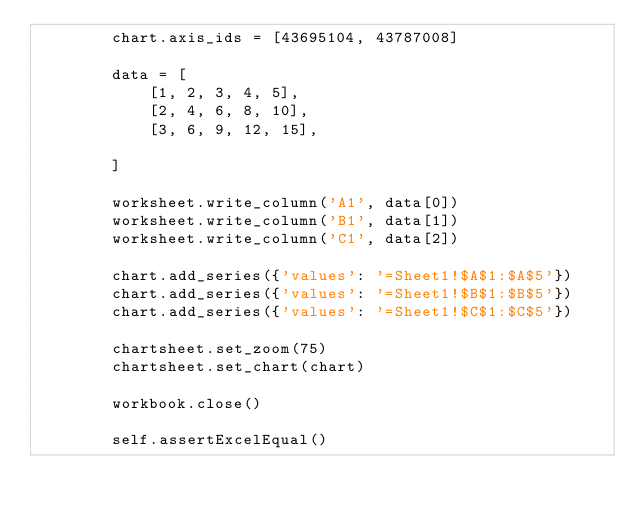Convert code to text. <code><loc_0><loc_0><loc_500><loc_500><_Python_>        chart.axis_ids = [43695104, 43787008]

        data = [
            [1, 2, 3, 4, 5],
            [2, 4, 6, 8, 10],
            [3, 6, 9, 12, 15],

        ]

        worksheet.write_column('A1', data[0])
        worksheet.write_column('B1', data[1])
        worksheet.write_column('C1', data[2])

        chart.add_series({'values': '=Sheet1!$A$1:$A$5'})
        chart.add_series({'values': '=Sheet1!$B$1:$B$5'})
        chart.add_series({'values': '=Sheet1!$C$1:$C$5'})

        chartsheet.set_zoom(75)
        chartsheet.set_chart(chart)

        workbook.close()

        self.assertExcelEqual()
</code> 